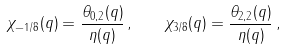<formula> <loc_0><loc_0><loc_500><loc_500>\chi _ { - 1 / 8 } ( q ) = \frac { \theta _ { 0 , 2 } ( q ) } { \eta ( q ) } \, , \quad \chi _ { 3 / 8 } ( q ) = \frac { \theta _ { 2 , 2 } ( q ) } { \eta ( q ) } \, ,</formula> 